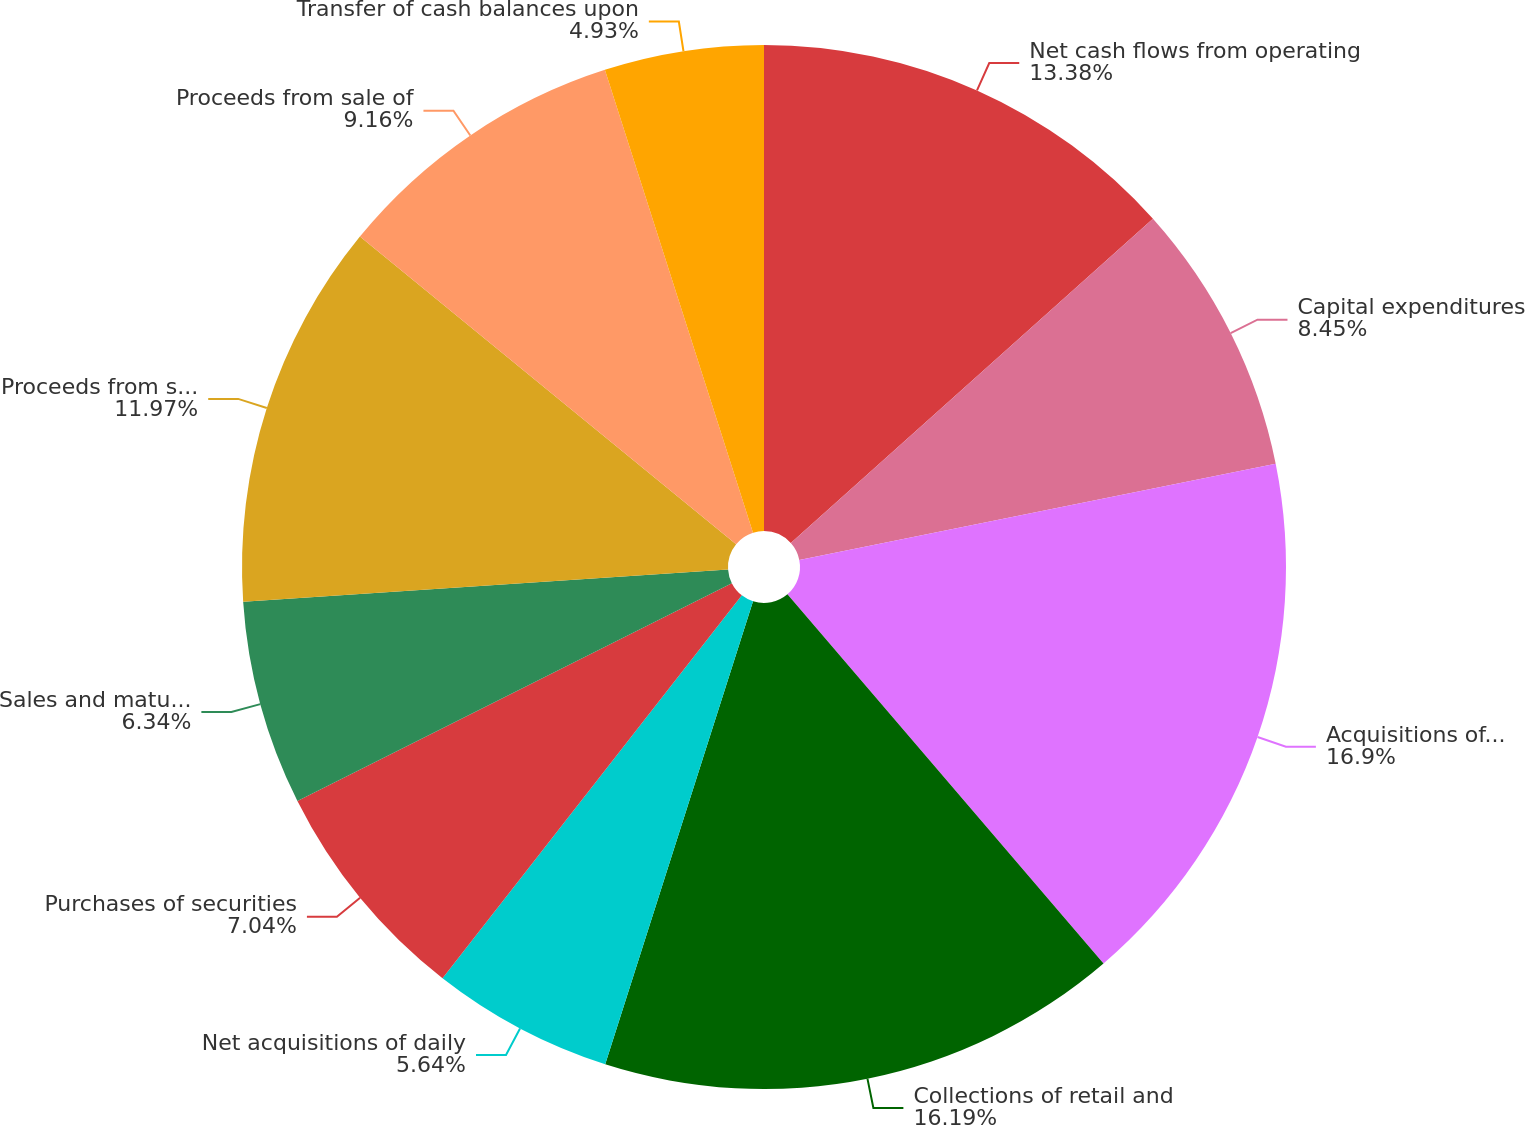Convert chart to OTSL. <chart><loc_0><loc_0><loc_500><loc_500><pie_chart><fcel>Net cash flows from operating<fcel>Capital expenditures<fcel>Acquisitions of retail and<fcel>Collections of retail and<fcel>Net acquisitions of daily<fcel>Purchases of securities<fcel>Sales and maturities of<fcel>Proceeds from sales of retail<fcel>Proceeds from sale of<fcel>Transfer of cash balances upon<nl><fcel>13.38%<fcel>8.45%<fcel>16.9%<fcel>16.19%<fcel>5.64%<fcel>7.04%<fcel>6.34%<fcel>11.97%<fcel>9.16%<fcel>4.93%<nl></chart> 